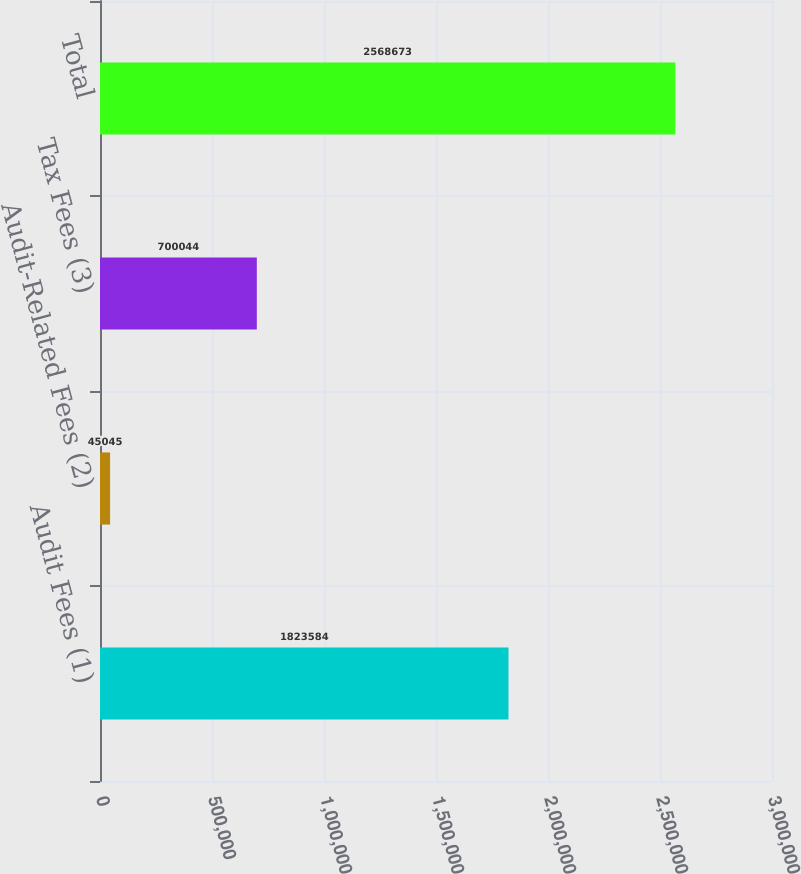Convert chart. <chart><loc_0><loc_0><loc_500><loc_500><bar_chart><fcel>Audit Fees (1)<fcel>Audit-Related Fees (2)<fcel>Tax Fees (3)<fcel>Total<nl><fcel>1.82358e+06<fcel>45045<fcel>700044<fcel>2.56867e+06<nl></chart> 